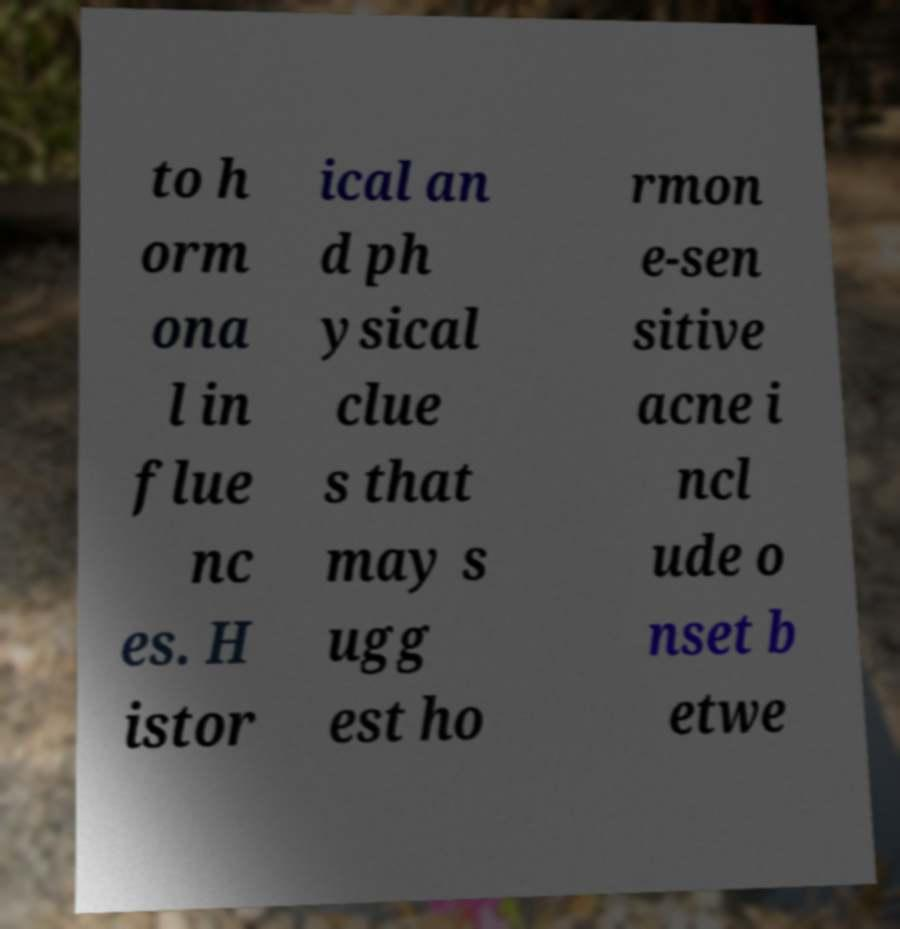Please identify and transcribe the text found in this image. to h orm ona l in flue nc es. H istor ical an d ph ysical clue s that may s ugg est ho rmon e-sen sitive acne i ncl ude o nset b etwe 